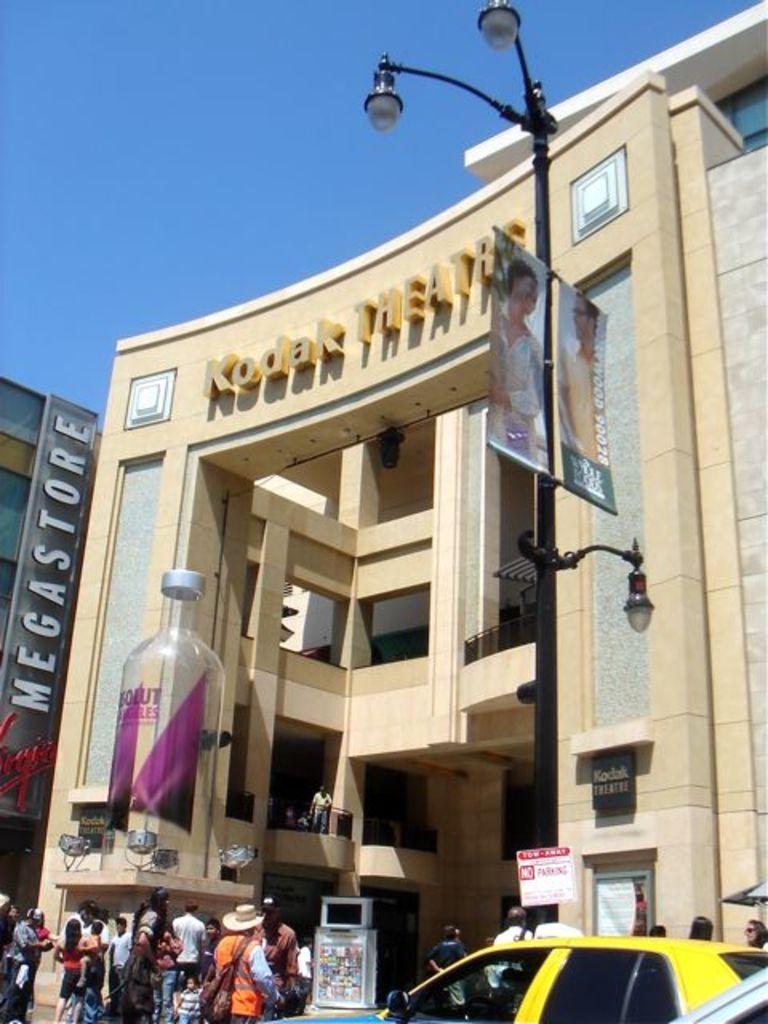Provide a one-sentence caption for the provided image. The front of the Kodak Theater in the middle of a sunny day. 